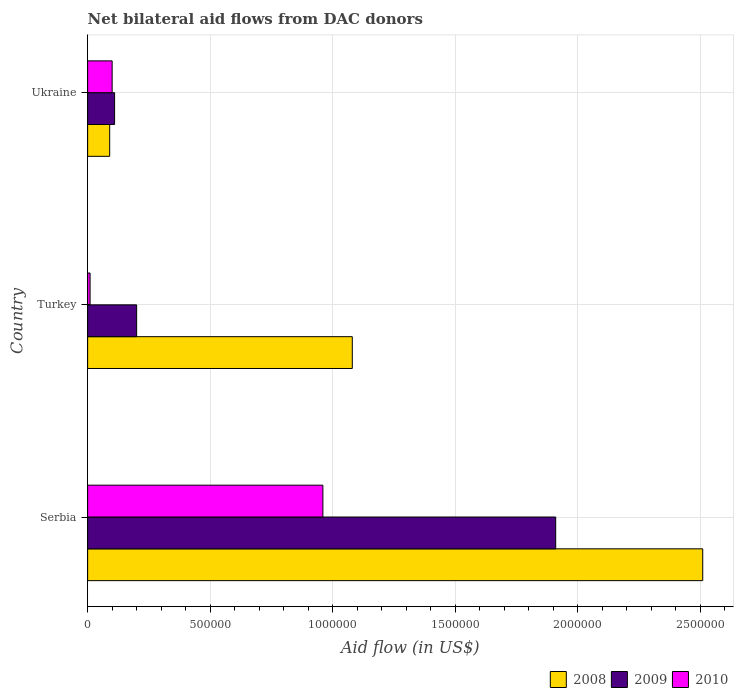Are the number of bars on each tick of the Y-axis equal?
Keep it short and to the point. Yes. What is the label of the 3rd group of bars from the top?
Your response must be concise. Serbia. Across all countries, what is the maximum net bilateral aid flow in 2008?
Offer a very short reply. 2.51e+06. Across all countries, what is the minimum net bilateral aid flow in 2008?
Provide a short and direct response. 9.00e+04. In which country was the net bilateral aid flow in 2010 maximum?
Give a very brief answer. Serbia. In which country was the net bilateral aid flow in 2008 minimum?
Your answer should be very brief. Ukraine. What is the total net bilateral aid flow in 2009 in the graph?
Your answer should be very brief. 2.22e+06. What is the difference between the net bilateral aid flow in 2009 in Ukraine and the net bilateral aid flow in 2008 in Turkey?
Ensure brevity in your answer.  -9.70e+05. What is the average net bilateral aid flow in 2009 per country?
Make the answer very short. 7.40e+05. What is the difference between the net bilateral aid flow in 2008 and net bilateral aid flow in 2010 in Turkey?
Offer a terse response. 1.07e+06. In how many countries, is the net bilateral aid flow in 2008 greater than 1800000 US$?
Make the answer very short. 1. What is the difference between the highest and the second highest net bilateral aid flow in 2009?
Make the answer very short. 1.71e+06. What is the difference between the highest and the lowest net bilateral aid flow in 2009?
Your answer should be compact. 1.80e+06. What does the 3rd bar from the top in Turkey represents?
Make the answer very short. 2008. What does the 3rd bar from the bottom in Serbia represents?
Provide a succinct answer. 2010. Is it the case that in every country, the sum of the net bilateral aid flow in 2009 and net bilateral aid flow in 2008 is greater than the net bilateral aid flow in 2010?
Ensure brevity in your answer.  Yes. How many bars are there?
Your answer should be very brief. 9. How many countries are there in the graph?
Your response must be concise. 3. What is the difference between two consecutive major ticks on the X-axis?
Your response must be concise. 5.00e+05. Where does the legend appear in the graph?
Make the answer very short. Bottom right. What is the title of the graph?
Offer a very short reply. Net bilateral aid flows from DAC donors. What is the label or title of the X-axis?
Your response must be concise. Aid flow (in US$). What is the label or title of the Y-axis?
Your answer should be very brief. Country. What is the Aid flow (in US$) in 2008 in Serbia?
Ensure brevity in your answer.  2.51e+06. What is the Aid flow (in US$) in 2009 in Serbia?
Ensure brevity in your answer.  1.91e+06. What is the Aid flow (in US$) in 2010 in Serbia?
Keep it short and to the point. 9.60e+05. What is the Aid flow (in US$) of 2008 in Turkey?
Your answer should be compact. 1.08e+06. What is the Aid flow (in US$) of 2010 in Turkey?
Your answer should be very brief. 10000. What is the Aid flow (in US$) in 2008 in Ukraine?
Your answer should be compact. 9.00e+04. Across all countries, what is the maximum Aid flow (in US$) in 2008?
Offer a terse response. 2.51e+06. Across all countries, what is the maximum Aid flow (in US$) in 2009?
Your answer should be very brief. 1.91e+06. Across all countries, what is the maximum Aid flow (in US$) in 2010?
Keep it short and to the point. 9.60e+05. Across all countries, what is the minimum Aid flow (in US$) in 2008?
Make the answer very short. 9.00e+04. Across all countries, what is the minimum Aid flow (in US$) in 2009?
Your response must be concise. 1.10e+05. What is the total Aid flow (in US$) in 2008 in the graph?
Keep it short and to the point. 3.68e+06. What is the total Aid flow (in US$) in 2009 in the graph?
Provide a succinct answer. 2.22e+06. What is the total Aid flow (in US$) in 2010 in the graph?
Provide a short and direct response. 1.07e+06. What is the difference between the Aid flow (in US$) in 2008 in Serbia and that in Turkey?
Provide a short and direct response. 1.43e+06. What is the difference between the Aid flow (in US$) in 2009 in Serbia and that in Turkey?
Make the answer very short. 1.71e+06. What is the difference between the Aid flow (in US$) in 2010 in Serbia and that in Turkey?
Provide a short and direct response. 9.50e+05. What is the difference between the Aid flow (in US$) in 2008 in Serbia and that in Ukraine?
Your answer should be compact. 2.42e+06. What is the difference between the Aid flow (in US$) in 2009 in Serbia and that in Ukraine?
Give a very brief answer. 1.80e+06. What is the difference between the Aid flow (in US$) in 2010 in Serbia and that in Ukraine?
Provide a succinct answer. 8.60e+05. What is the difference between the Aid flow (in US$) in 2008 in Turkey and that in Ukraine?
Ensure brevity in your answer.  9.90e+05. What is the difference between the Aid flow (in US$) of 2008 in Serbia and the Aid flow (in US$) of 2009 in Turkey?
Ensure brevity in your answer.  2.31e+06. What is the difference between the Aid flow (in US$) in 2008 in Serbia and the Aid flow (in US$) in 2010 in Turkey?
Your answer should be very brief. 2.50e+06. What is the difference between the Aid flow (in US$) of 2009 in Serbia and the Aid flow (in US$) of 2010 in Turkey?
Your response must be concise. 1.90e+06. What is the difference between the Aid flow (in US$) in 2008 in Serbia and the Aid flow (in US$) in 2009 in Ukraine?
Give a very brief answer. 2.40e+06. What is the difference between the Aid flow (in US$) of 2008 in Serbia and the Aid flow (in US$) of 2010 in Ukraine?
Make the answer very short. 2.41e+06. What is the difference between the Aid flow (in US$) in 2009 in Serbia and the Aid flow (in US$) in 2010 in Ukraine?
Your answer should be compact. 1.81e+06. What is the difference between the Aid flow (in US$) in 2008 in Turkey and the Aid flow (in US$) in 2009 in Ukraine?
Provide a succinct answer. 9.70e+05. What is the difference between the Aid flow (in US$) of 2008 in Turkey and the Aid flow (in US$) of 2010 in Ukraine?
Offer a terse response. 9.80e+05. What is the average Aid flow (in US$) in 2008 per country?
Offer a very short reply. 1.23e+06. What is the average Aid flow (in US$) in 2009 per country?
Give a very brief answer. 7.40e+05. What is the average Aid flow (in US$) of 2010 per country?
Make the answer very short. 3.57e+05. What is the difference between the Aid flow (in US$) in 2008 and Aid flow (in US$) in 2009 in Serbia?
Keep it short and to the point. 6.00e+05. What is the difference between the Aid flow (in US$) in 2008 and Aid flow (in US$) in 2010 in Serbia?
Make the answer very short. 1.55e+06. What is the difference between the Aid flow (in US$) in 2009 and Aid flow (in US$) in 2010 in Serbia?
Keep it short and to the point. 9.50e+05. What is the difference between the Aid flow (in US$) of 2008 and Aid flow (in US$) of 2009 in Turkey?
Offer a very short reply. 8.80e+05. What is the difference between the Aid flow (in US$) in 2008 and Aid flow (in US$) in 2010 in Turkey?
Make the answer very short. 1.07e+06. What is the difference between the Aid flow (in US$) of 2008 and Aid flow (in US$) of 2009 in Ukraine?
Your answer should be very brief. -2.00e+04. What is the ratio of the Aid flow (in US$) of 2008 in Serbia to that in Turkey?
Make the answer very short. 2.32. What is the ratio of the Aid flow (in US$) of 2009 in Serbia to that in Turkey?
Your response must be concise. 9.55. What is the ratio of the Aid flow (in US$) in 2010 in Serbia to that in Turkey?
Provide a short and direct response. 96. What is the ratio of the Aid flow (in US$) of 2008 in Serbia to that in Ukraine?
Offer a terse response. 27.89. What is the ratio of the Aid flow (in US$) of 2009 in Serbia to that in Ukraine?
Make the answer very short. 17.36. What is the ratio of the Aid flow (in US$) in 2010 in Serbia to that in Ukraine?
Make the answer very short. 9.6. What is the ratio of the Aid flow (in US$) of 2009 in Turkey to that in Ukraine?
Give a very brief answer. 1.82. What is the ratio of the Aid flow (in US$) of 2010 in Turkey to that in Ukraine?
Offer a very short reply. 0.1. What is the difference between the highest and the second highest Aid flow (in US$) in 2008?
Ensure brevity in your answer.  1.43e+06. What is the difference between the highest and the second highest Aid flow (in US$) of 2009?
Keep it short and to the point. 1.71e+06. What is the difference between the highest and the second highest Aid flow (in US$) in 2010?
Offer a very short reply. 8.60e+05. What is the difference between the highest and the lowest Aid flow (in US$) in 2008?
Your response must be concise. 2.42e+06. What is the difference between the highest and the lowest Aid flow (in US$) of 2009?
Provide a succinct answer. 1.80e+06. What is the difference between the highest and the lowest Aid flow (in US$) of 2010?
Your answer should be very brief. 9.50e+05. 